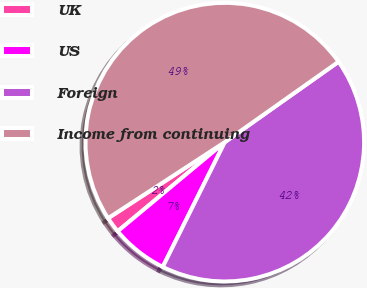Convert chart to OTSL. <chart><loc_0><loc_0><loc_500><loc_500><pie_chart><fcel>UK<fcel>US<fcel>Foreign<fcel>Income from continuing<nl><fcel>1.85%<fcel>6.61%<fcel>42.14%<fcel>49.41%<nl></chart> 